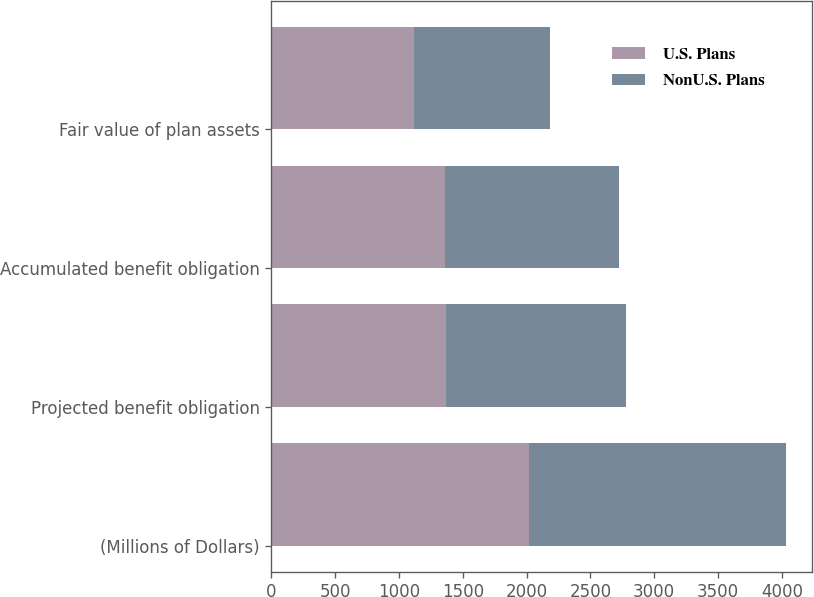Convert chart. <chart><loc_0><loc_0><loc_500><loc_500><stacked_bar_chart><ecel><fcel>(Millions of Dollars)<fcel>Projected benefit obligation<fcel>Accumulated benefit obligation<fcel>Fair value of plan assets<nl><fcel>U.S. Plans<fcel>2017<fcel>1365.3<fcel>1358.4<fcel>1114.1<nl><fcel>NonU.S. Plans<fcel>2017<fcel>1415.9<fcel>1368.7<fcel>1068.5<nl></chart> 